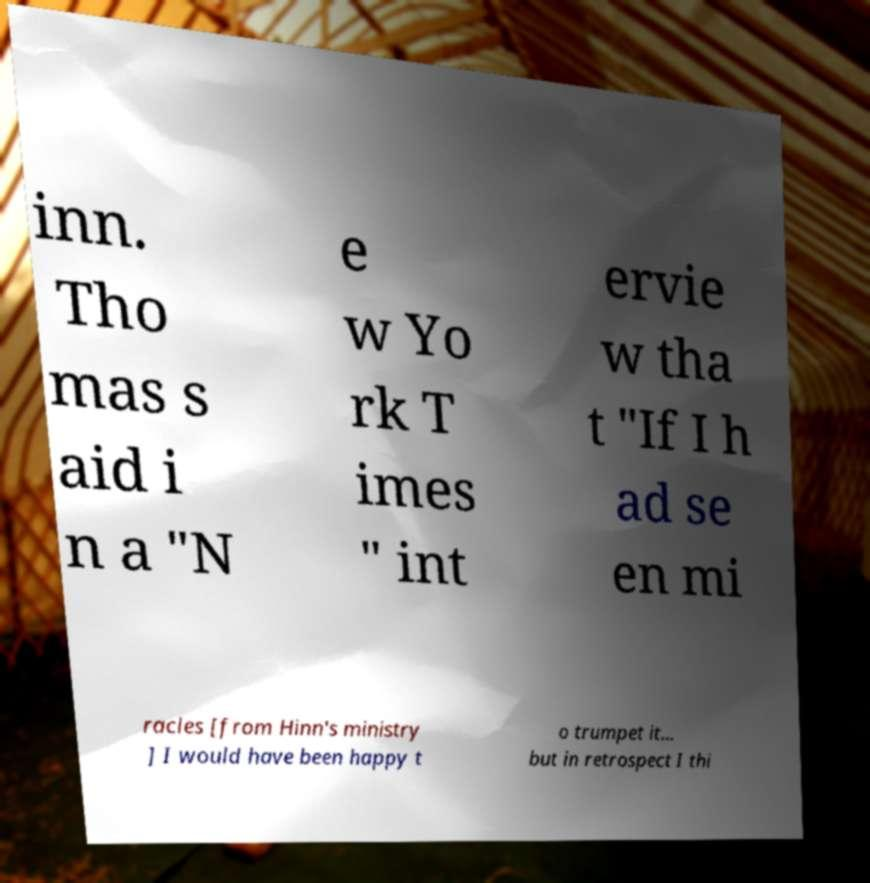Can you accurately transcribe the text from the provided image for me? inn. Tho mas s aid i n a "N e w Yo rk T imes " int ervie w tha t "If I h ad se en mi racles [from Hinn's ministry ] I would have been happy t o trumpet it... but in retrospect I thi 